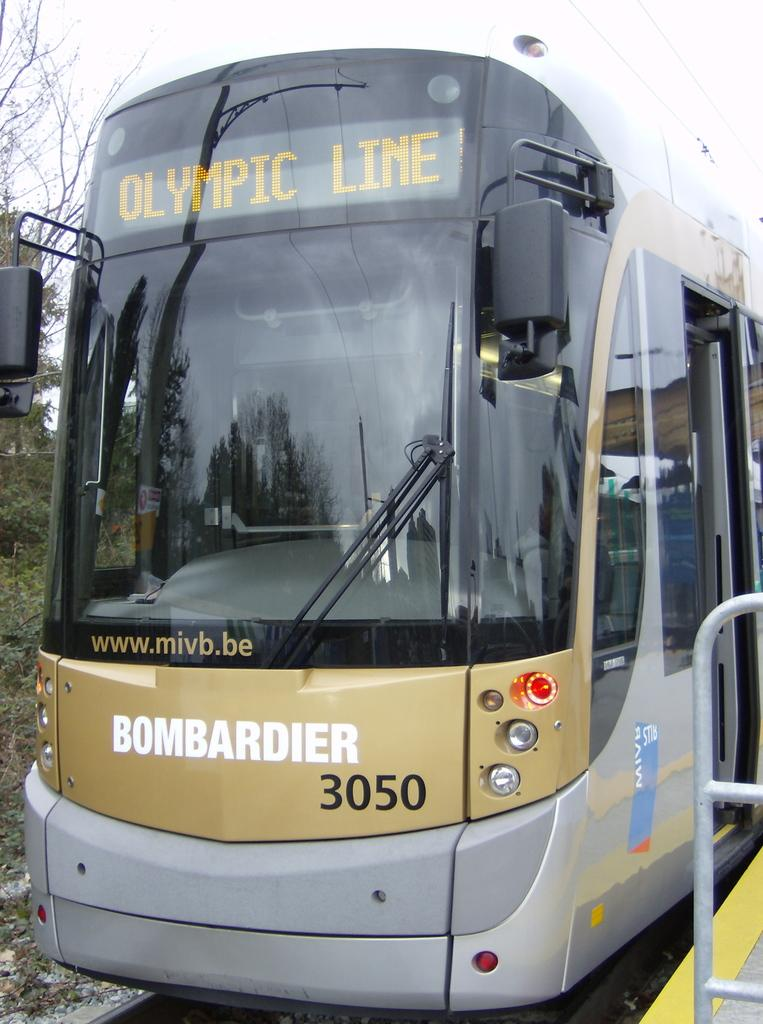What is the main subject of the image? The main subject of the image is a bus. What is located beside the bus in the image? There is a platform beside the bus in the image. What can be seen on the left side of the image? There are trees on the left side of the image. Can you see a toad wearing a coat in the shade under the trees? There is no toad or coat visible in the image; only the bus, platform, and trees are present. 